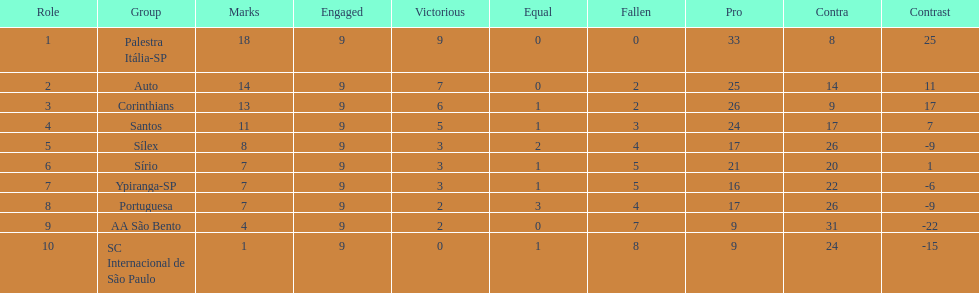Which team managed to achieve 13 points in just 9 games? Corinthians. 